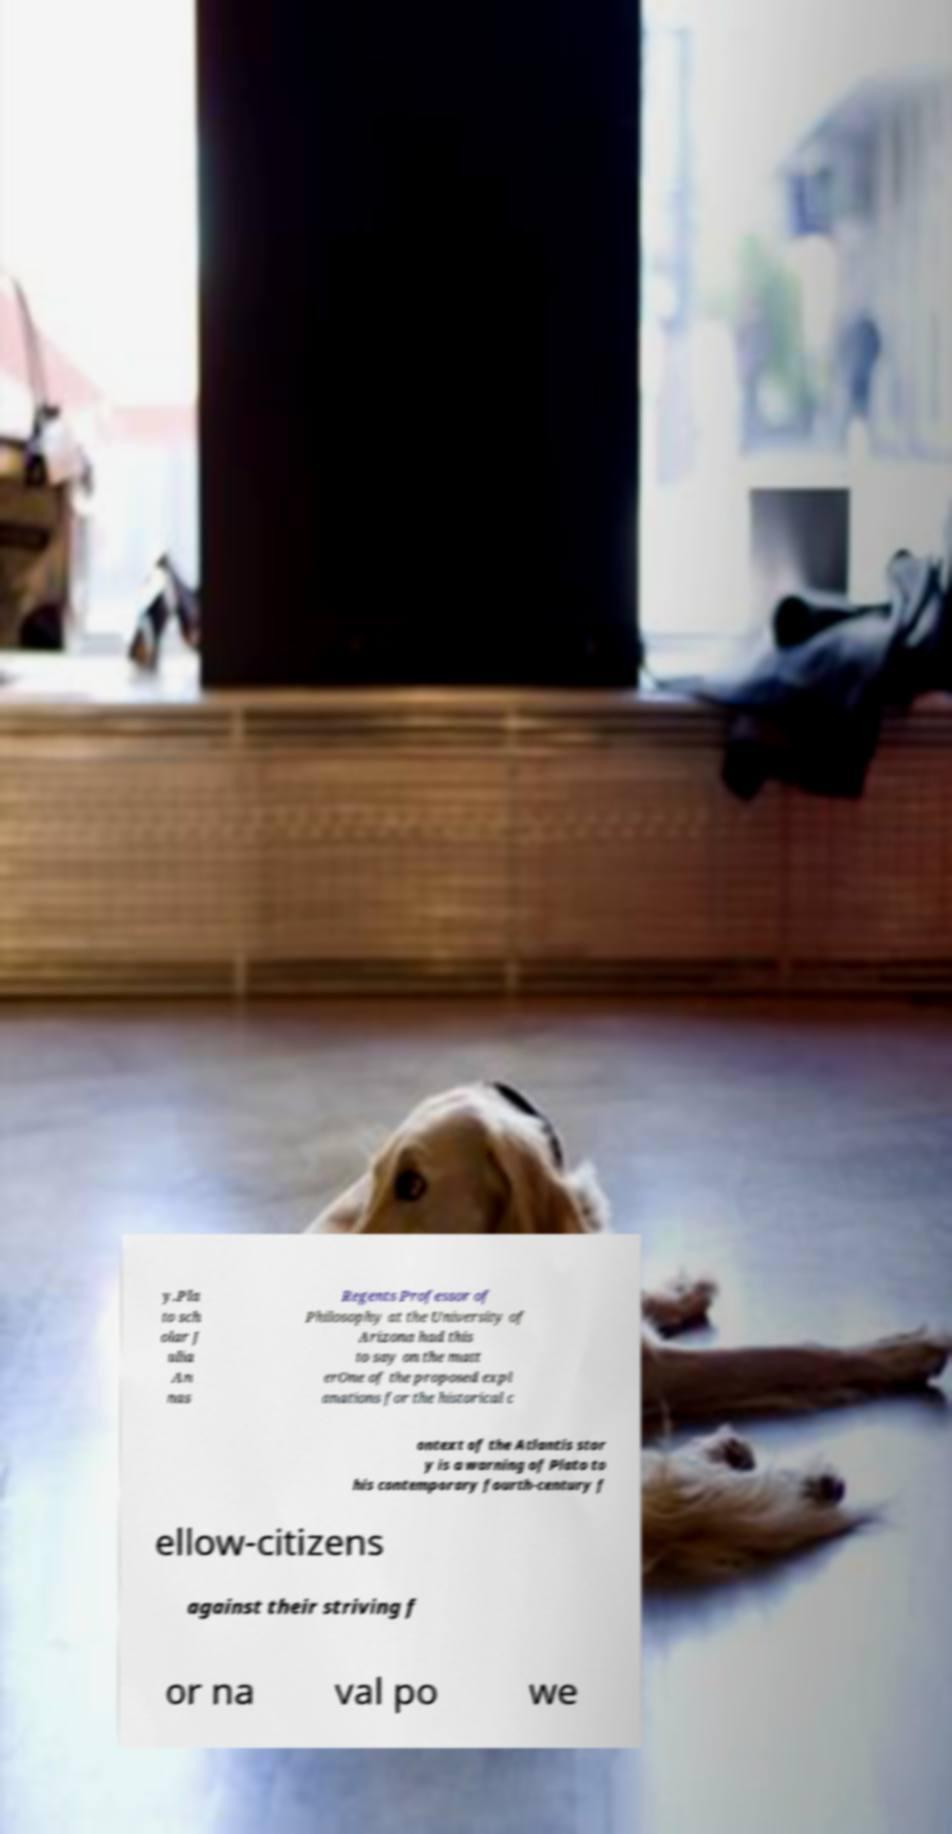I need the written content from this picture converted into text. Can you do that? y.Pla to sch olar J ulia An nas Regents Professor of Philosophy at the University of Arizona had this to say on the matt erOne of the proposed expl anations for the historical c ontext of the Atlantis stor y is a warning of Plato to his contemporary fourth-century f ellow-citizens against their striving f or na val po we 